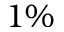<formula> <loc_0><loc_0><loc_500><loc_500>1 \%</formula> 